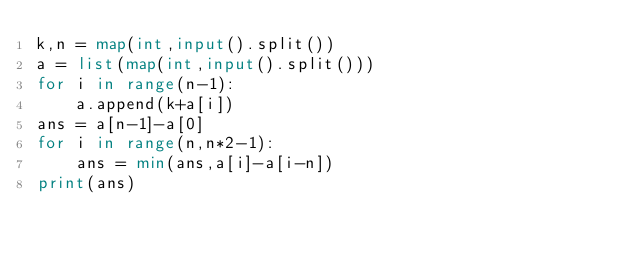Convert code to text. <code><loc_0><loc_0><loc_500><loc_500><_Python_>k,n = map(int,input().split())
a = list(map(int,input().split()))
for i in range(n-1):
    a.append(k+a[i])
ans = a[n-1]-a[0]
for i in range(n,n*2-1):
    ans = min(ans,a[i]-a[i-n])
print(ans)</code> 